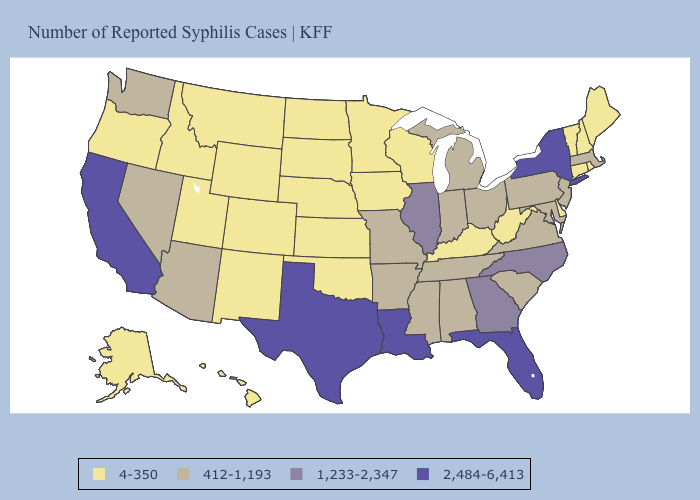What is the value of Minnesota?
Give a very brief answer. 4-350. What is the lowest value in states that border Connecticut?
Give a very brief answer. 4-350. Name the states that have a value in the range 412-1,193?
Give a very brief answer. Alabama, Arizona, Arkansas, Indiana, Maryland, Massachusetts, Michigan, Mississippi, Missouri, Nevada, New Jersey, Ohio, Pennsylvania, South Carolina, Tennessee, Virginia, Washington. Name the states that have a value in the range 1,233-2,347?
Concise answer only. Georgia, Illinois, North Carolina. Among the states that border New York , does Connecticut have the highest value?
Write a very short answer. No. What is the highest value in states that border Montana?
Answer briefly. 4-350. Does the map have missing data?
Concise answer only. No. Name the states that have a value in the range 1,233-2,347?
Quick response, please. Georgia, Illinois, North Carolina. Is the legend a continuous bar?
Answer briefly. No. Name the states that have a value in the range 412-1,193?
Be succinct. Alabama, Arizona, Arkansas, Indiana, Maryland, Massachusetts, Michigan, Mississippi, Missouri, Nevada, New Jersey, Ohio, Pennsylvania, South Carolina, Tennessee, Virginia, Washington. What is the lowest value in the South?
Concise answer only. 4-350. What is the value of Mississippi?
Give a very brief answer. 412-1,193. Does New York have the highest value in the USA?
Keep it brief. Yes. Does Utah have the same value as Iowa?
Be succinct. Yes. What is the value of Illinois?
Concise answer only. 1,233-2,347. 